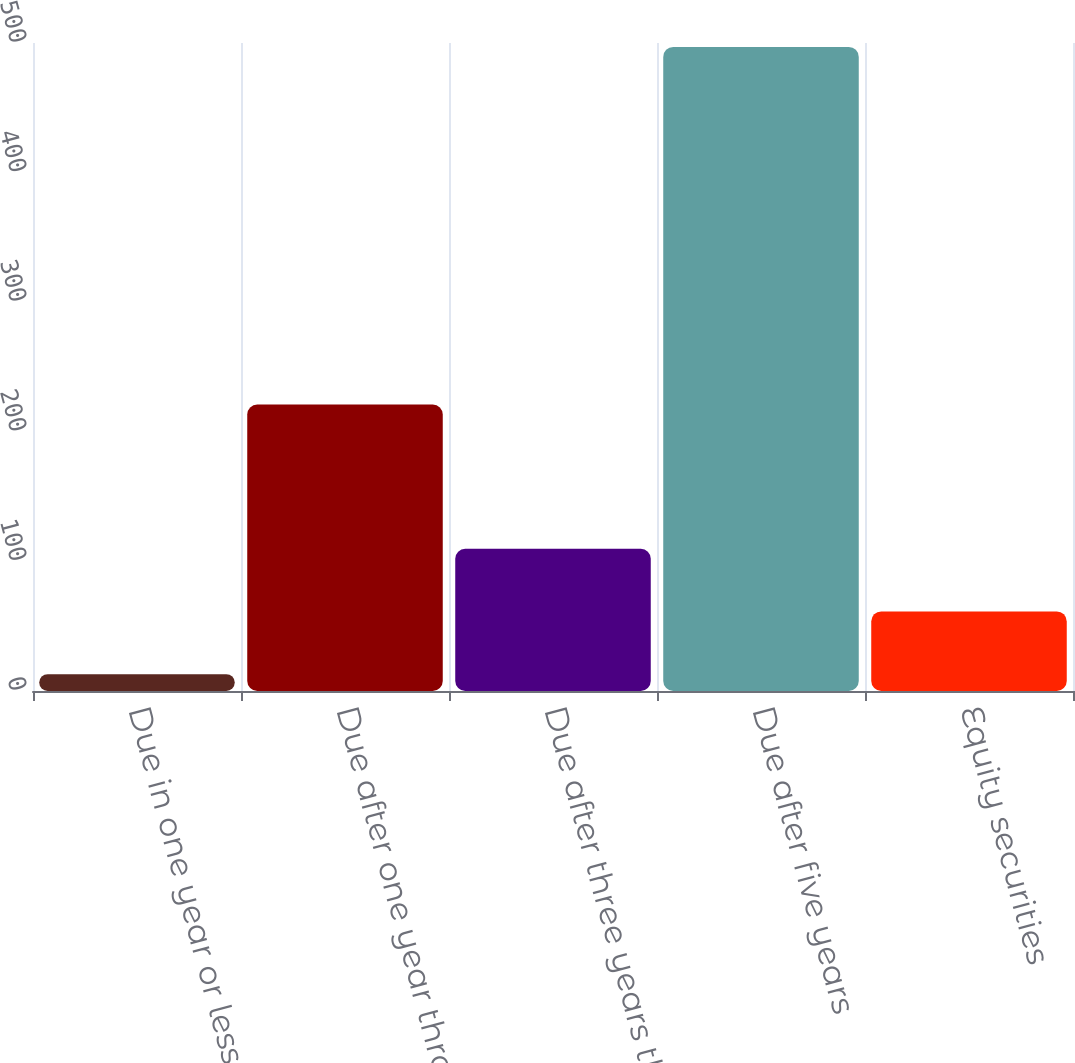<chart> <loc_0><loc_0><loc_500><loc_500><bar_chart><fcel>Due in one year or less<fcel>Due after one year through<fcel>Due after three years through<fcel>Due after five years<fcel>Equity securities<nl><fcel>13<fcel>221<fcel>109.8<fcel>497<fcel>61.4<nl></chart> 